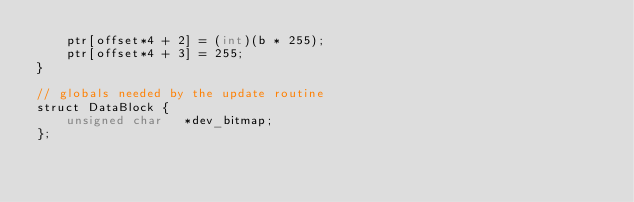Convert code to text. <code><loc_0><loc_0><loc_500><loc_500><_Cuda_>    ptr[offset*4 + 2] = (int)(b * 255);
    ptr[offset*4 + 3] = 255;
}

// globals needed by the update routine
struct DataBlock {
    unsigned char   *dev_bitmap;
};
</code> 